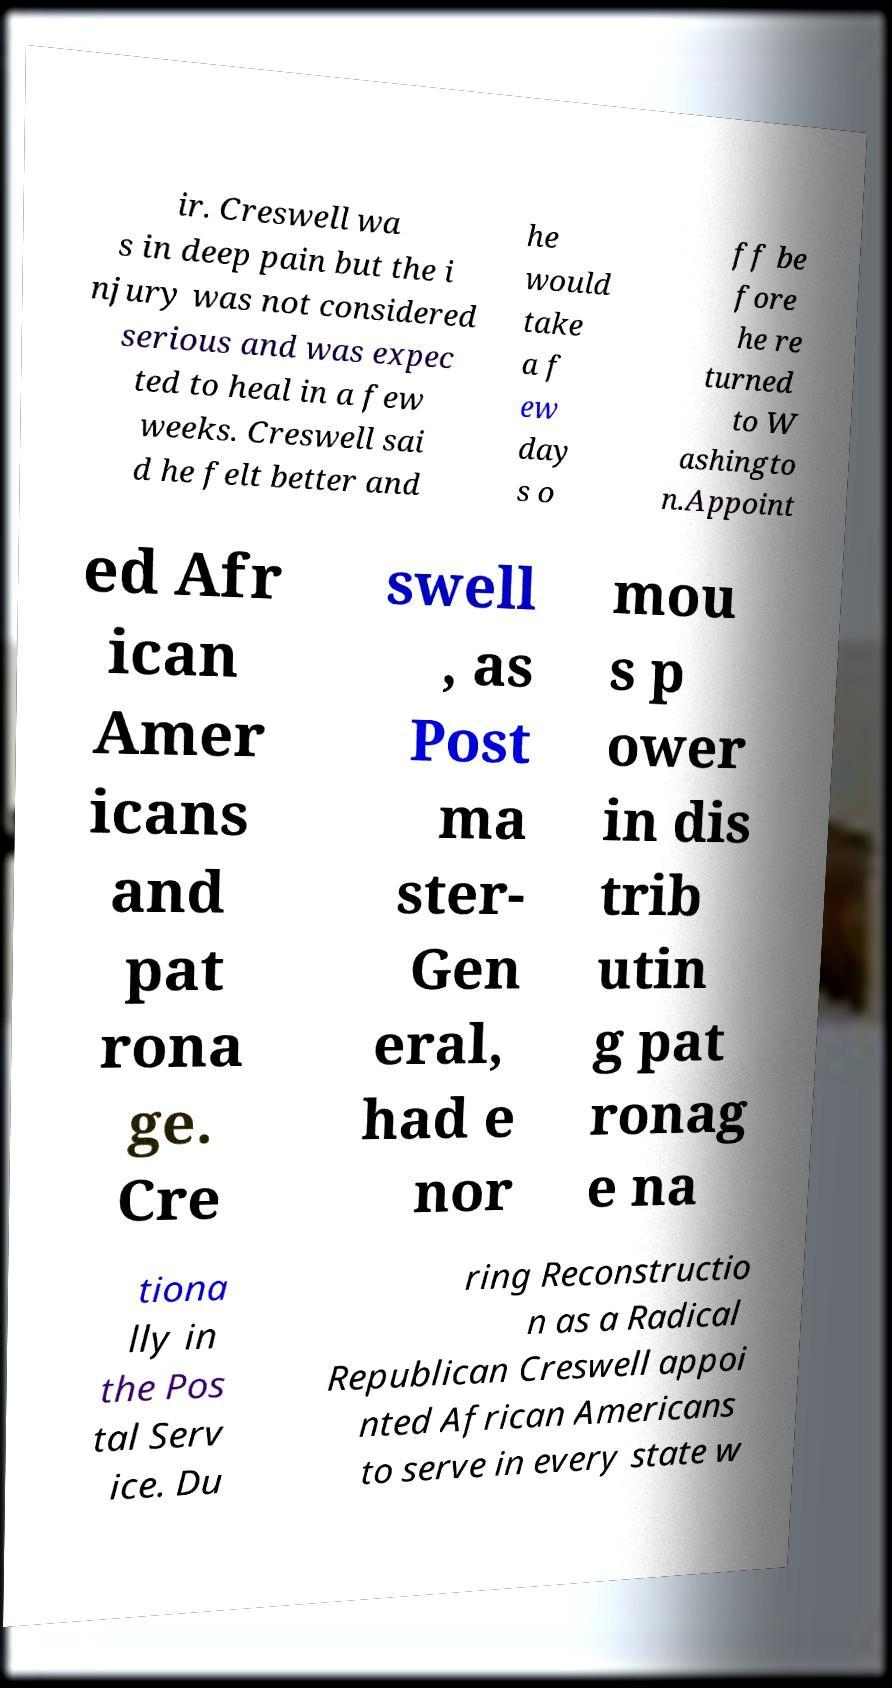What messages or text are displayed in this image? I need them in a readable, typed format. ir. Creswell wa s in deep pain but the i njury was not considered serious and was expec ted to heal in a few weeks. Creswell sai d he felt better and he would take a f ew day s o ff be fore he re turned to W ashingto n.Appoint ed Afr ican Amer icans and pat rona ge. Cre swell , as Post ma ster- Gen eral, had e nor mou s p ower in dis trib utin g pat ronag e na tiona lly in the Pos tal Serv ice. Du ring Reconstructio n as a Radical Republican Creswell appoi nted African Americans to serve in every state w 